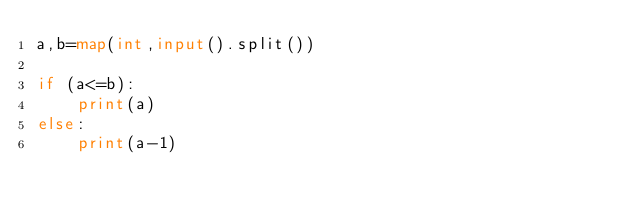Convert code to text. <code><loc_0><loc_0><loc_500><loc_500><_Python_>a,b=map(int,input().split())

if (a<=b):
    print(a)
else:
    print(a-1)

</code> 